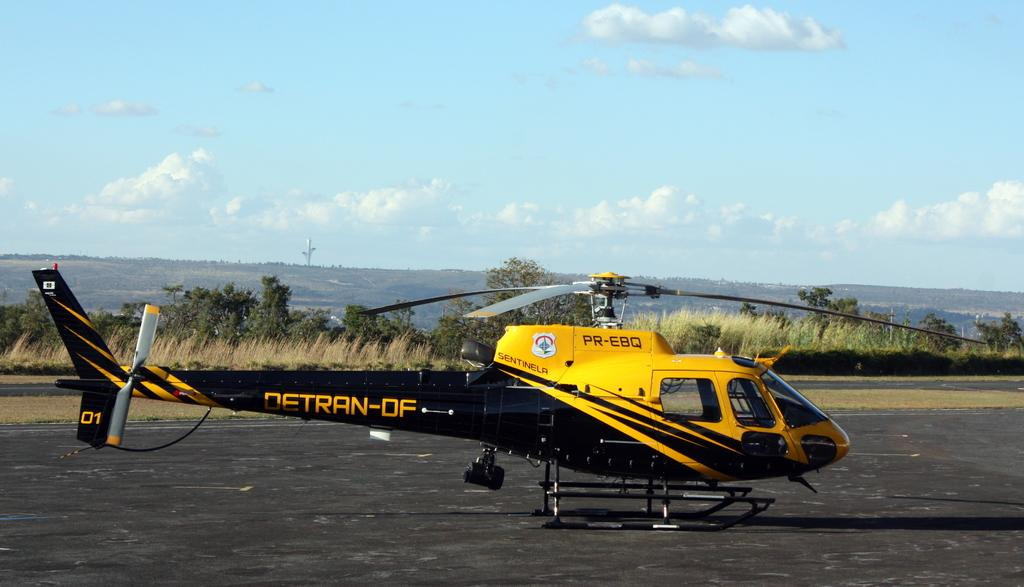Provide a one-sentence caption for the provided image. A black and yellow Detran-DF  helicopter is ready to go on a clear day. 